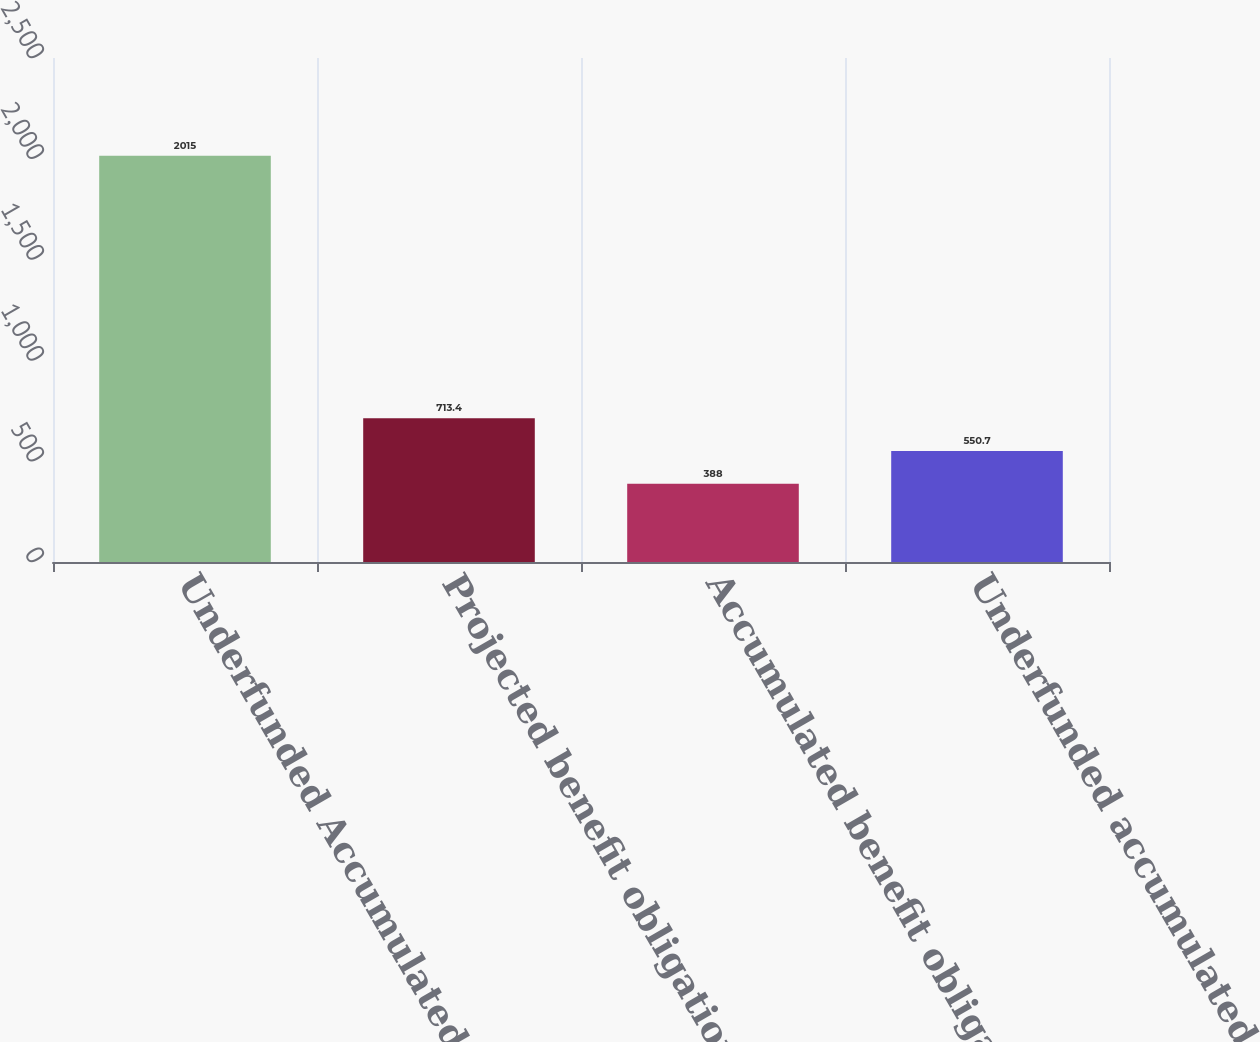Convert chart to OTSL. <chart><loc_0><loc_0><loc_500><loc_500><bar_chart><fcel>Underfunded Accumulated<fcel>Projected benefit obligation<fcel>Accumulated benefit obligation<fcel>Underfunded accumulated<nl><fcel>2015<fcel>713.4<fcel>388<fcel>550.7<nl></chart> 